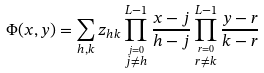Convert formula to latex. <formula><loc_0><loc_0><loc_500><loc_500>\Phi ( x , y ) = \sum _ { h , k } z _ { h k } \prod _ { \stackrel { j = 0 } { j \neq h } } ^ { L - 1 } \frac { x - j } { h - j } \prod _ { \stackrel { r = 0 } { r \neq k } } ^ { L - 1 } \frac { y - r } { k - r }</formula> 